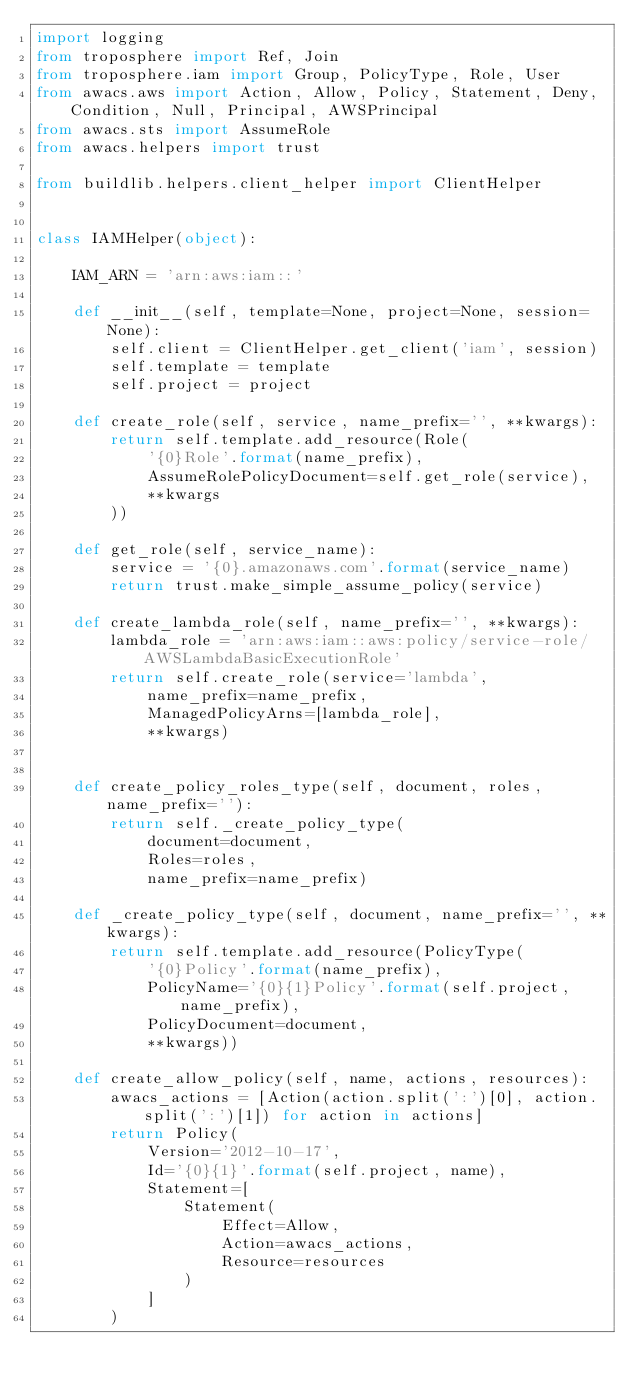<code> <loc_0><loc_0><loc_500><loc_500><_Python_>import logging
from troposphere import Ref, Join
from troposphere.iam import Group, PolicyType, Role, User
from awacs.aws import Action, Allow, Policy, Statement, Deny, Condition, Null, Principal, AWSPrincipal
from awacs.sts import AssumeRole
from awacs.helpers import trust

from buildlib.helpers.client_helper import ClientHelper


class IAMHelper(object):

    IAM_ARN = 'arn:aws:iam::'

    def __init__(self, template=None, project=None, session=None):
        self.client = ClientHelper.get_client('iam', session)
        self.template = template
        self.project = project

    def create_role(self, service, name_prefix='', **kwargs):
        return self.template.add_resource(Role(
            '{0}Role'.format(name_prefix),
            AssumeRolePolicyDocument=self.get_role(service),
            **kwargs
        ))

    def get_role(self, service_name):
        service = '{0}.amazonaws.com'.format(service_name)
        return trust.make_simple_assume_policy(service)

    def create_lambda_role(self, name_prefix='', **kwargs):
        lambda_role = 'arn:aws:iam::aws:policy/service-role/AWSLambdaBasicExecutionRole'
        return self.create_role(service='lambda',
            name_prefix=name_prefix,
            ManagedPolicyArns=[lambda_role],
            **kwargs)


    def create_policy_roles_type(self, document, roles, name_prefix=''):
        return self._create_policy_type(
            document=document,
            Roles=roles,
            name_prefix=name_prefix)

    def _create_policy_type(self, document, name_prefix='', **kwargs):
        return self.template.add_resource(PolicyType(
            '{0}Policy'.format(name_prefix),
            PolicyName='{0}{1}Policy'.format(self.project, name_prefix),
            PolicyDocument=document,
            **kwargs))

    def create_allow_policy(self, name, actions, resources):
        awacs_actions = [Action(action.split(':')[0], action.split(':')[1]) for action in actions]
        return Policy(
            Version='2012-10-17',
            Id='{0}{1}'.format(self.project, name),
            Statement=[
                Statement(
                    Effect=Allow,
                    Action=awacs_actions,
                    Resource=resources
                )
            ]
        )



</code> 